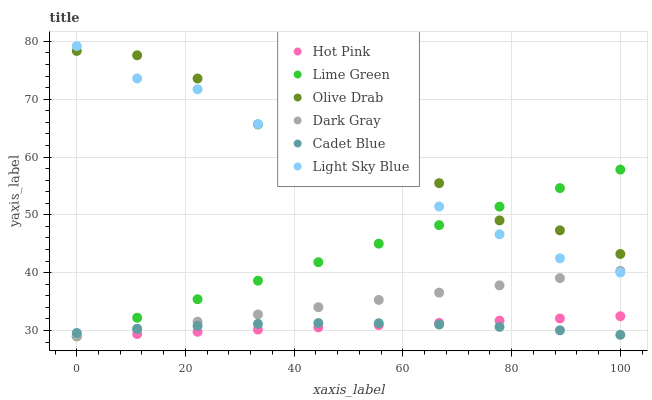Does Cadet Blue have the minimum area under the curve?
Answer yes or no. Yes. Does Olive Drab have the maximum area under the curve?
Answer yes or no. Yes. Does Hot Pink have the minimum area under the curve?
Answer yes or no. No. Does Hot Pink have the maximum area under the curve?
Answer yes or no. No. Is Lime Green the smoothest?
Answer yes or no. Yes. Is Olive Drab the roughest?
Answer yes or no. Yes. Is Hot Pink the smoothest?
Answer yes or no. No. Is Hot Pink the roughest?
Answer yes or no. No. Does Hot Pink have the lowest value?
Answer yes or no. Yes. Does Light Sky Blue have the lowest value?
Answer yes or no. No. Does Light Sky Blue have the highest value?
Answer yes or no. Yes. Does Hot Pink have the highest value?
Answer yes or no. No. Is Cadet Blue less than Light Sky Blue?
Answer yes or no. Yes. Is Light Sky Blue greater than Cadet Blue?
Answer yes or no. Yes. Does Dark Gray intersect Hot Pink?
Answer yes or no. Yes. Is Dark Gray less than Hot Pink?
Answer yes or no. No. Is Dark Gray greater than Hot Pink?
Answer yes or no. No. Does Cadet Blue intersect Light Sky Blue?
Answer yes or no. No. 